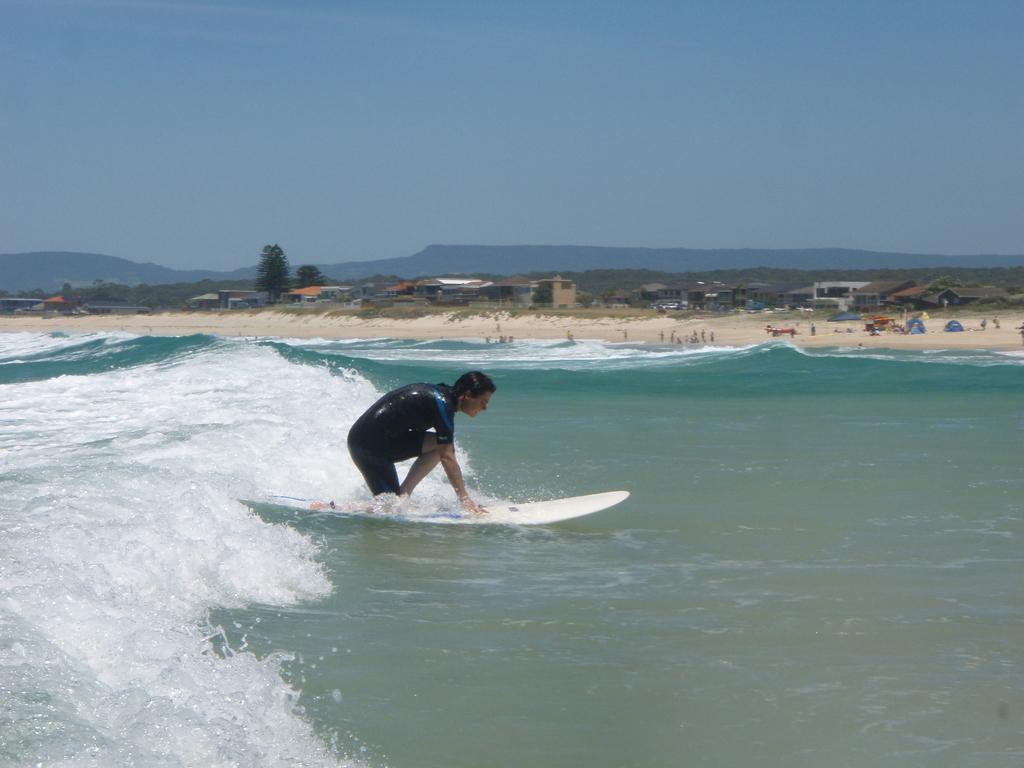Describe this image in one or two sentences. In this picture we can see a man is surfing with a surfboard on the water. Behind the man there are houses, trees, hills and the sky. 